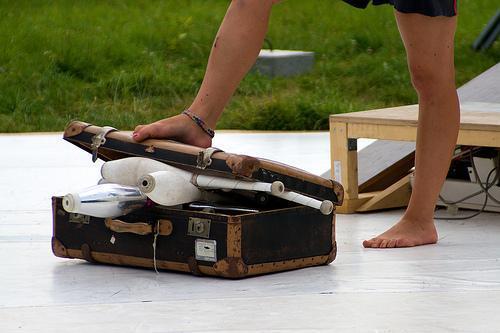How many bowling pins are there?
Give a very brief answer. 3. 